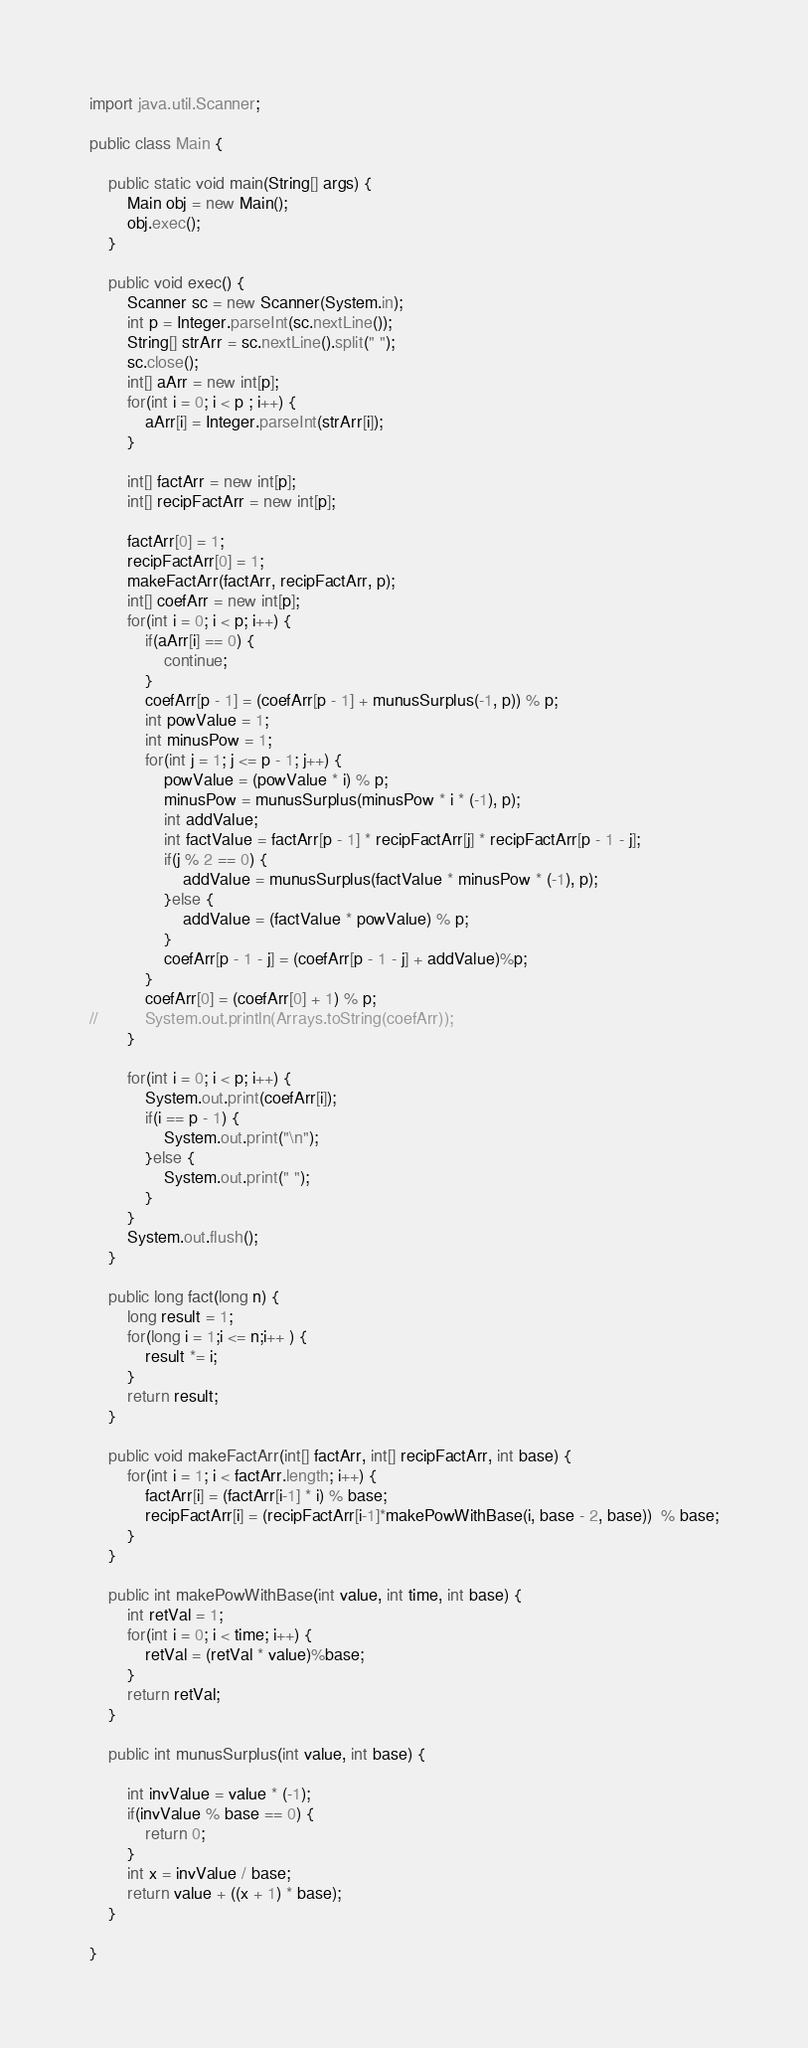<code> <loc_0><loc_0><loc_500><loc_500><_Java_>import java.util.Scanner;

public class Main {
	
	public static void main(String[] args) {
		Main obj = new Main();
		obj.exec();
	}
	
	public void exec() {
		Scanner sc = new Scanner(System.in);
		int p = Integer.parseInt(sc.nextLine());
		String[] strArr = sc.nextLine().split(" ");
		sc.close();
		int[] aArr = new int[p];
		for(int i = 0; i < p ; i++) {
			aArr[i] = Integer.parseInt(strArr[i]);
		}
		
		int[] factArr = new int[p];
		int[] recipFactArr = new int[p]; 
		
		factArr[0] = 1;
		recipFactArr[0] = 1; 
		makeFactArr(factArr, recipFactArr, p);
		int[] coefArr = new int[p];
		for(int i = 0; i < p; i++) {
			if(aArr[i] == 0) {
				continue;
			}
			coefArr[p - 1] = (coefArr[p - 1] + munusSurplus(-1, p)) % p;
			int powValue = 1;
			int minusPow = 1;
			for(int j = 1; j <= p - 1; j++) {
				powValue = (powValue * i) % p;
				minusPow = munusSurplus(minusPow * i * (-1), p);
				int addValue;
				int factValue = factArr[p - 1] * recipFactArr[j] * recipFactArr[p - 1 - j];
				if(j % 2 == 0) {
					addValue = munusSurplus(factValue * minusPow * (-1), p);
				}else {
					addValue = (factValue * powValue) % p;
				}
				coefArr[p - 1 - j] = (coefArr[p - 1 - j] + addValue)%p;
			}
			coefArr[0] = (coefArr[0] + 1) % p;
//			System.out.println(Arrays.toString(coefArr));
		}
		
		for(int i = 0; i < p; i++) {
			System.out.print(coefArr[i]);
			if(i == p - 1) {
				System.out.print("\n");
			}else {
				System.out.print(" ");
			}
		}
		System.out.flush();
	}
	
	public long fact(long n) {
		long result = 1;
		for(long i = 1;i <= n;i++ ) {
			result *= i;
		}
		return result;
	}
	
	public void makeFactArr(int[] factArr, int[] recipFactArr, int base) {
		for(int i = 1; i < factArr.length; i++) {
			factArr[i] = (factArr[i-1] * i) % base;
			recipFactArr[i] = (recipFactArr[i-1]*makePowWithBase(i, base - 2, base))  % base;
 		}
	}
	
	public int makePowWithBase(int value, int time, int base) {
		int retVal = 1;
		for(int i = 0; i < time; i++) {
			retVal = (retVal * value)%base;
		}
		return retVal;
	}
	
	public int munusSurplus(int value, int base) {

		int invValue = value * (-1);
		if(invValue % base == 0) {
			return 0;
		}
		int x = invValue / base;
		return value + ((x + 1) * base);
	}

}
</code> 